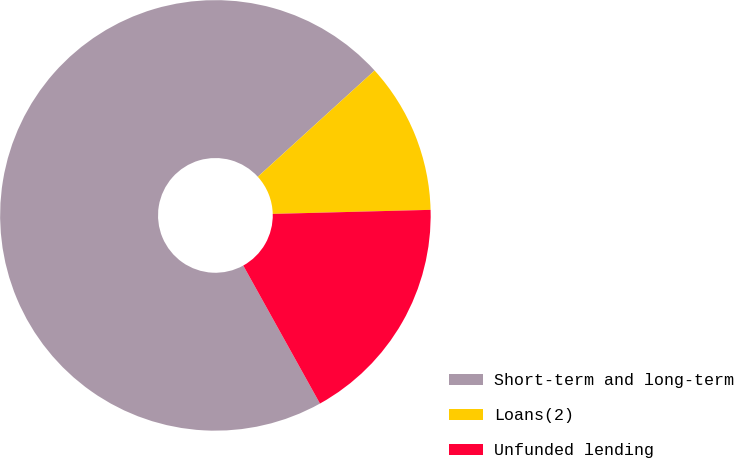<chart> <loc_0><loc_0><loc_500><loc_500><pie_chart><fcel>Short-term and long-term<fcel>Loans(2)<fcel>Unfunded lending<nl><fcel>71.33%<fcel>11.34%<fcel>17.34%<nl></chart> 